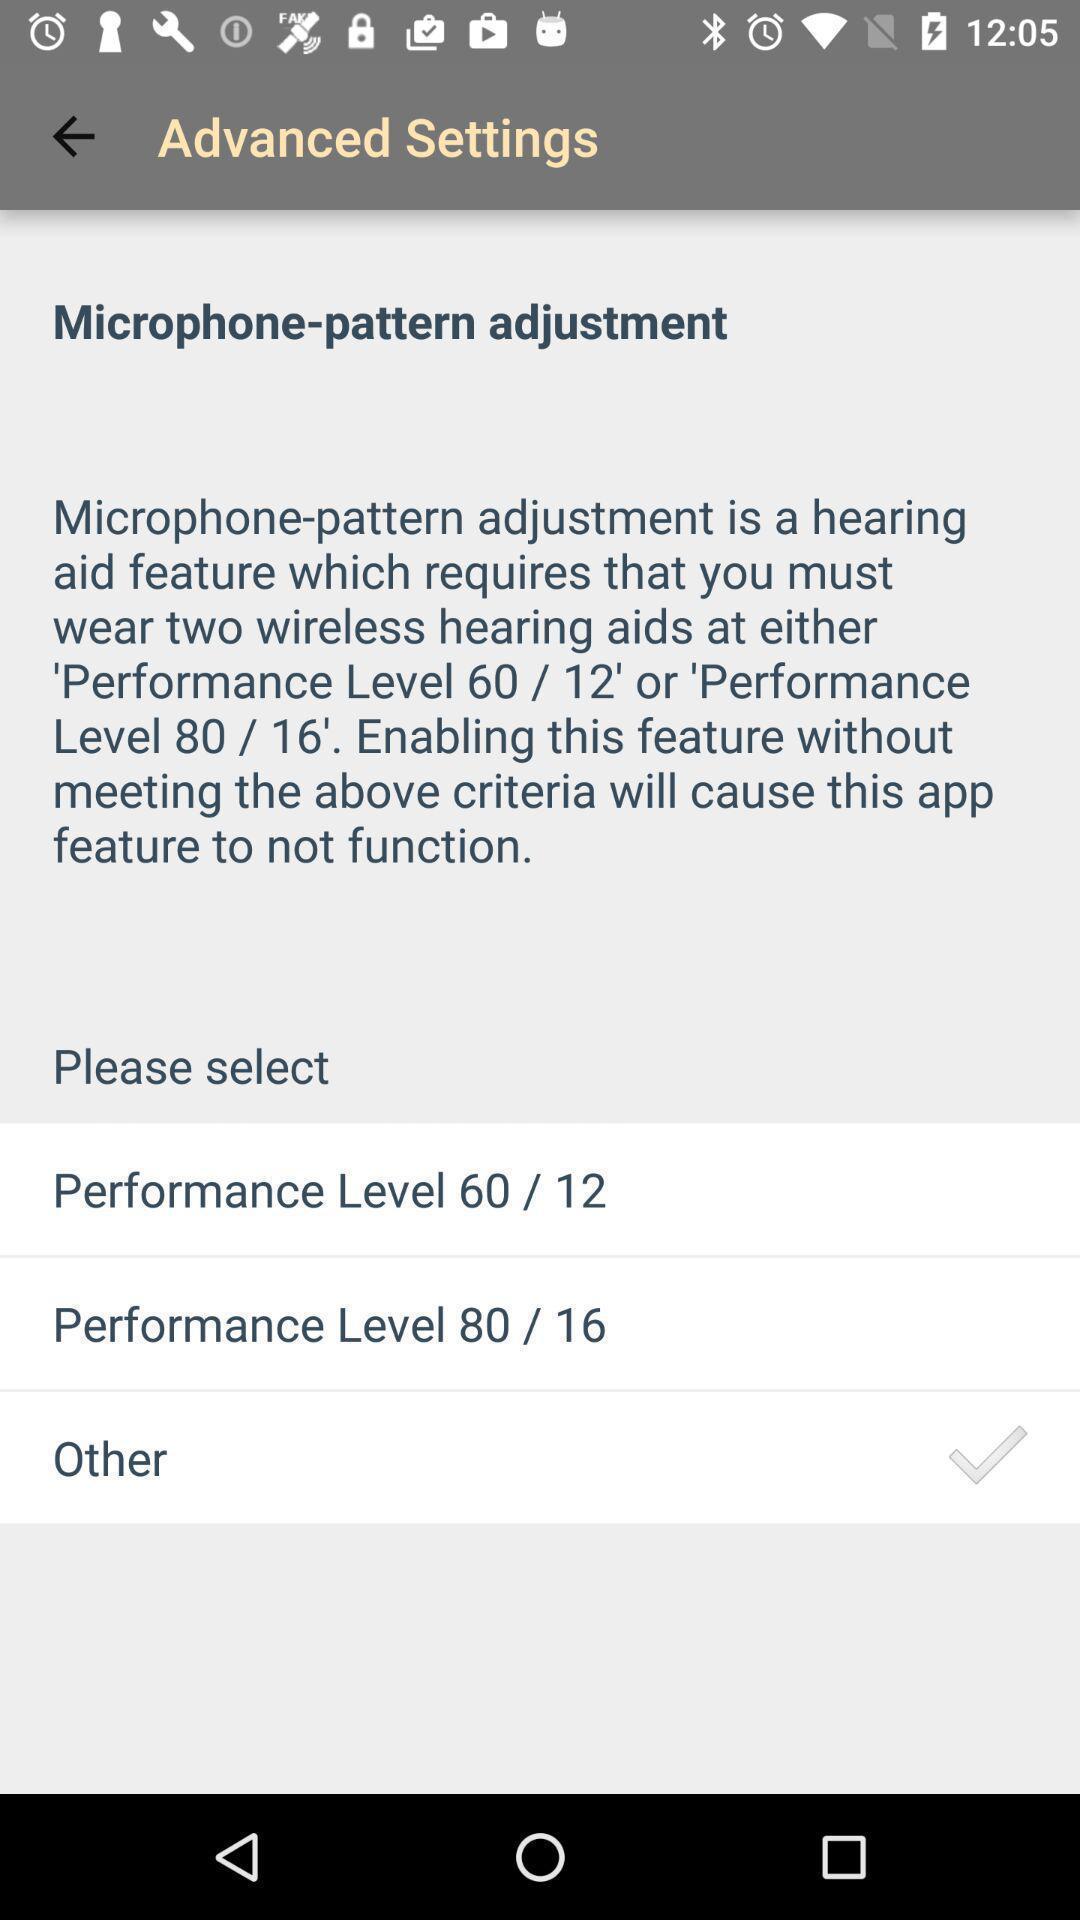Please provide a description for this image. Settings page. 